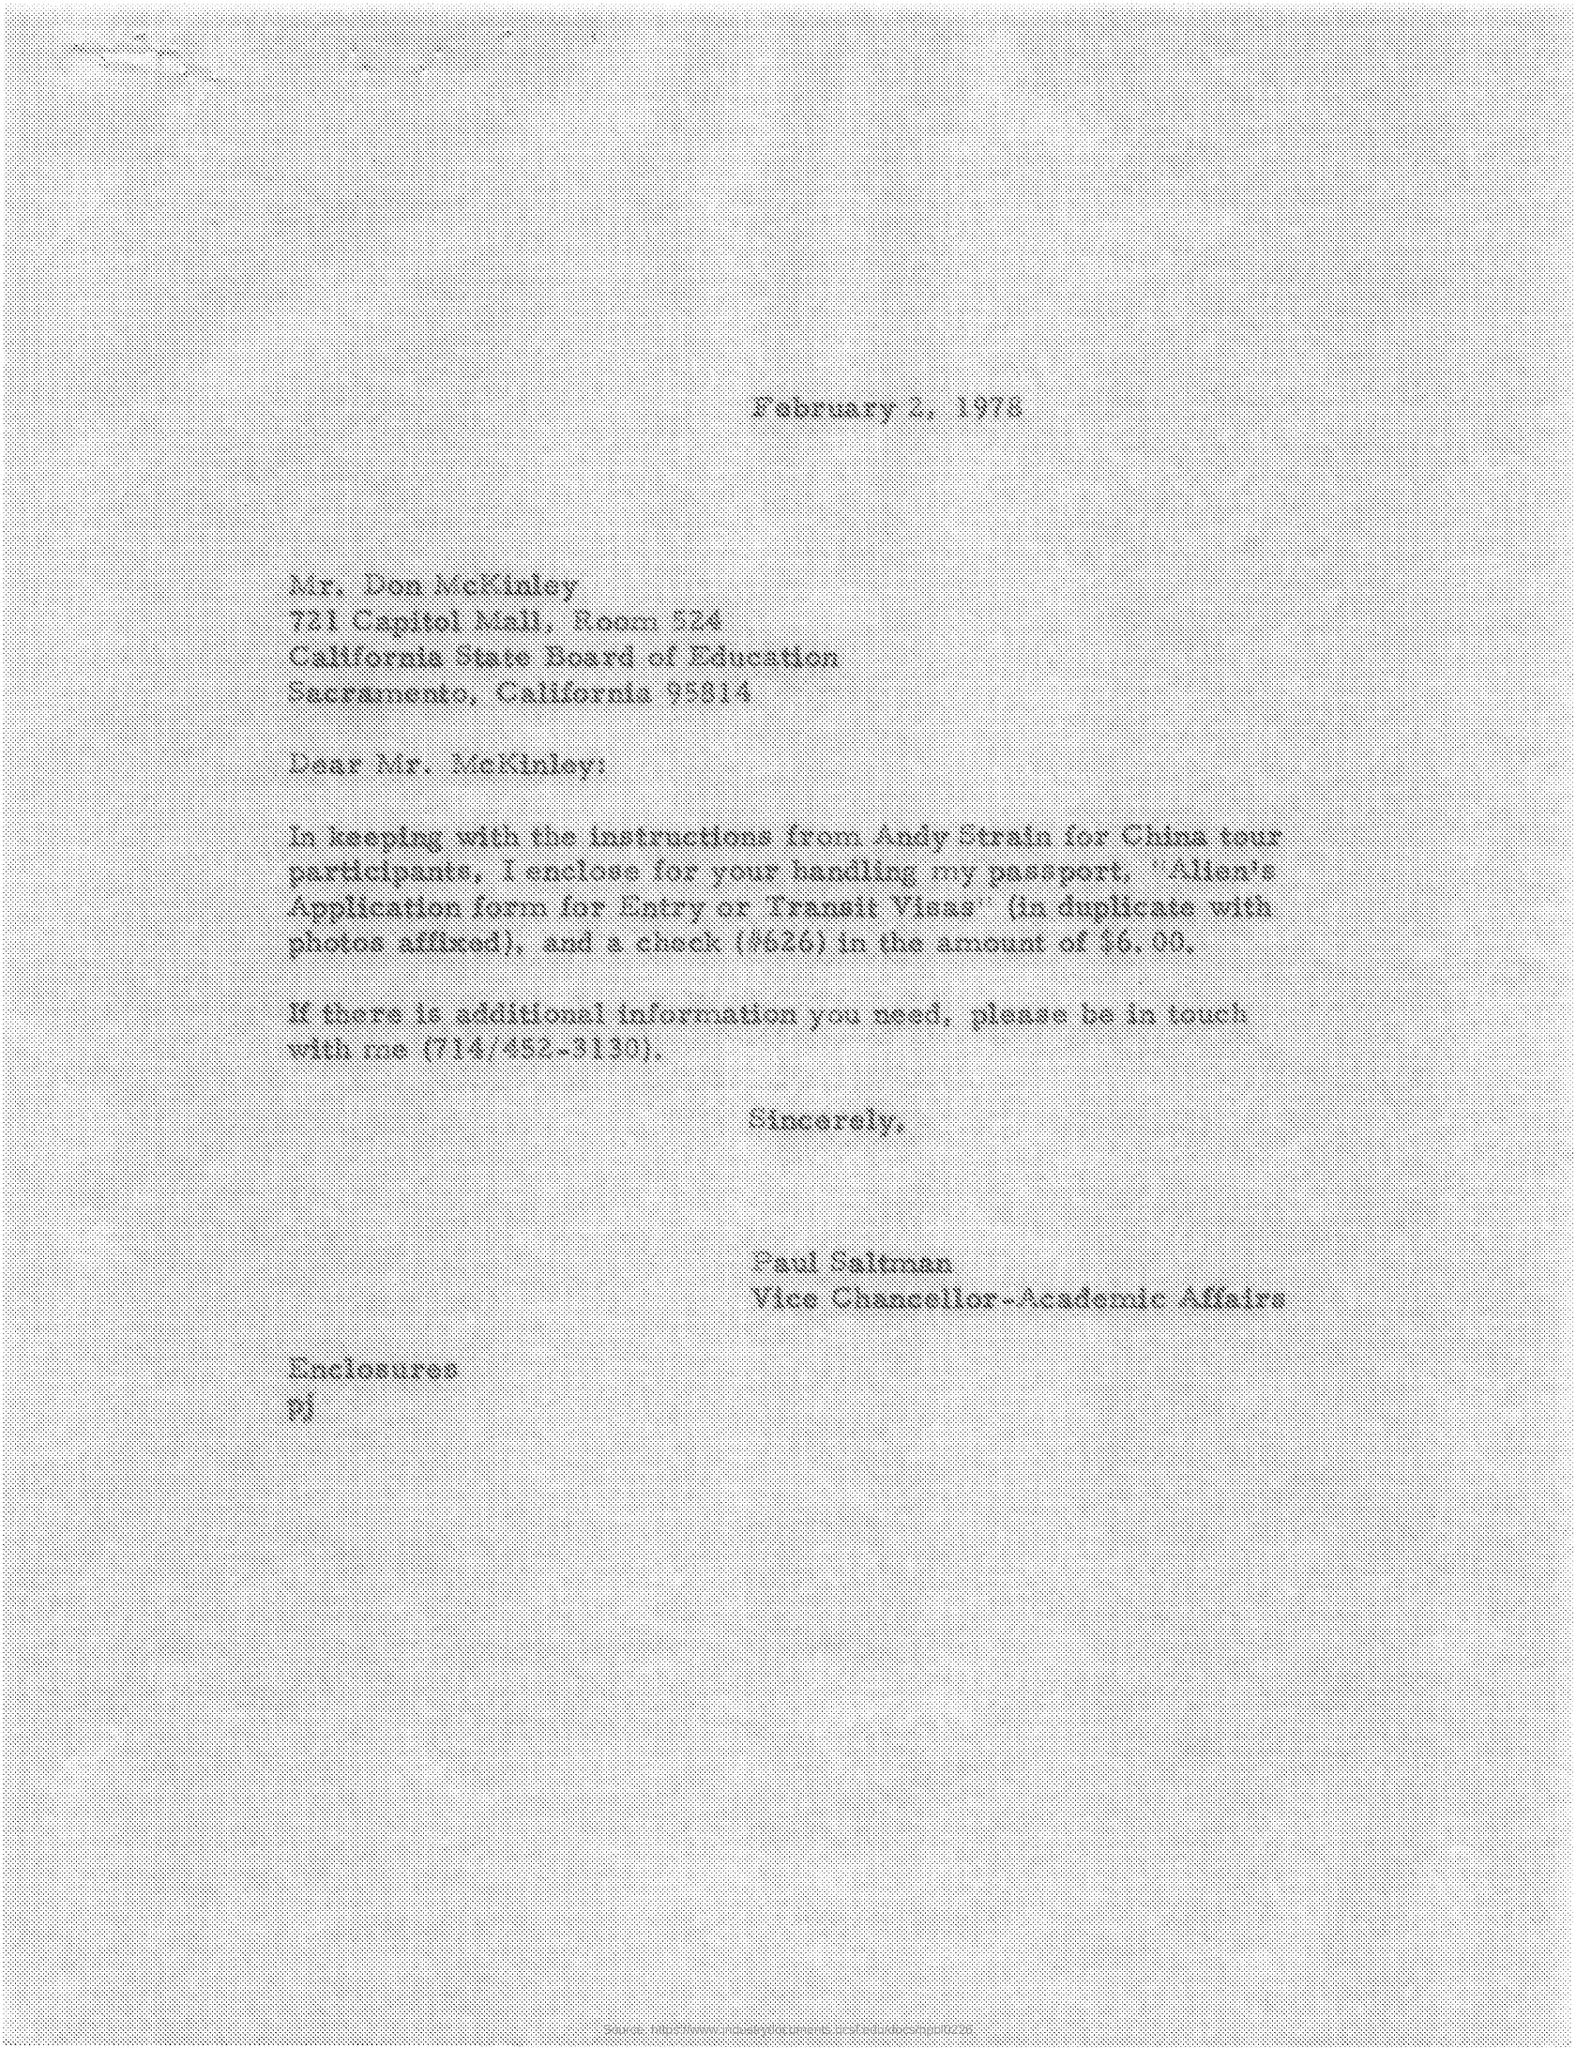What is the issued date of this letter?
Give a very brief answer. February 2, 1978. What is the designation of Paul Saltman?
Provide a succinct answer. Vice Chancellor-Academic Affairs. Who is the sender of this letter?
Your response must be concise. Paul Saltman. 